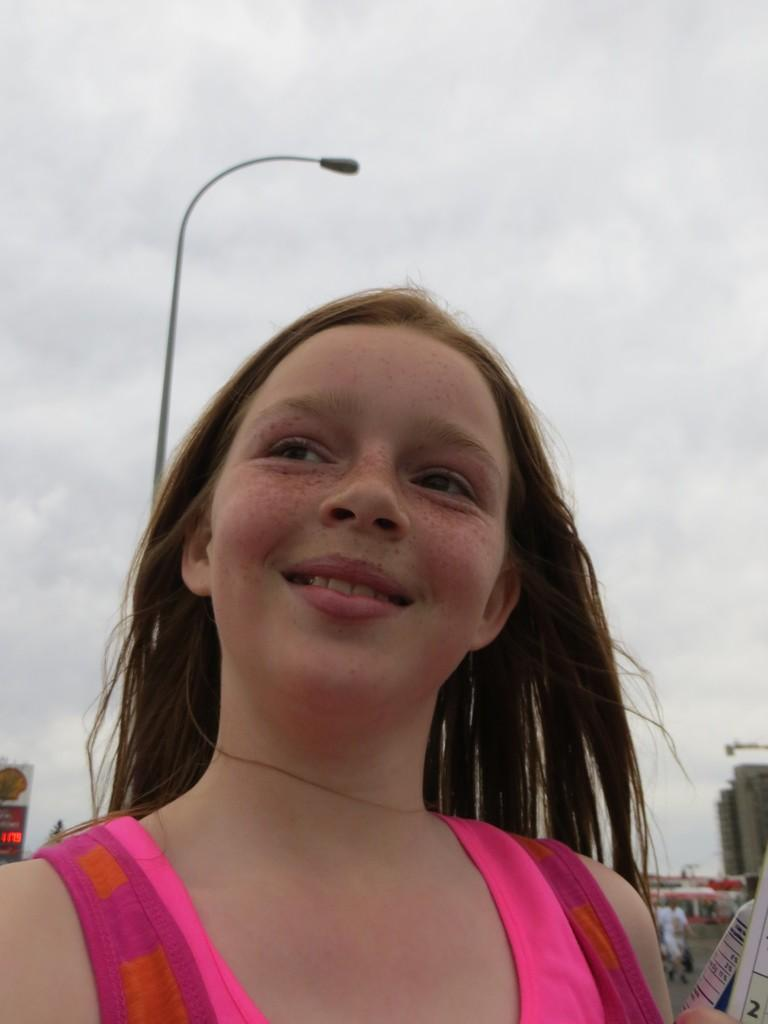Who is present in the image? There is a girl in the image. What is the girl's expression? The girl is smiling. What type of structure can be seen in the image? There is a building in the image. Can you describe any other objects in the image? There is a pole, a light, and a board in the image. What can be seen in the background of the image? The sky is visible in the background of the image. Reasoning: Let's think step by step by step in order to produce the conversation. We start by identifying the main subject in the image, which is the girl. Then, we describe her expression and expand the conversation to include other objects and structures visible in the image, such as the building, pole, light, and board. We also mention the sky visible in the background. Each question is designed to elicit a specific detail about the image that is known from the provided facts. Absurd Question/Answer: What type of feast is being prepared on the part in the image? There is no part or feast present in the image; it features a girl, a building, a pole, a light, and a board. 